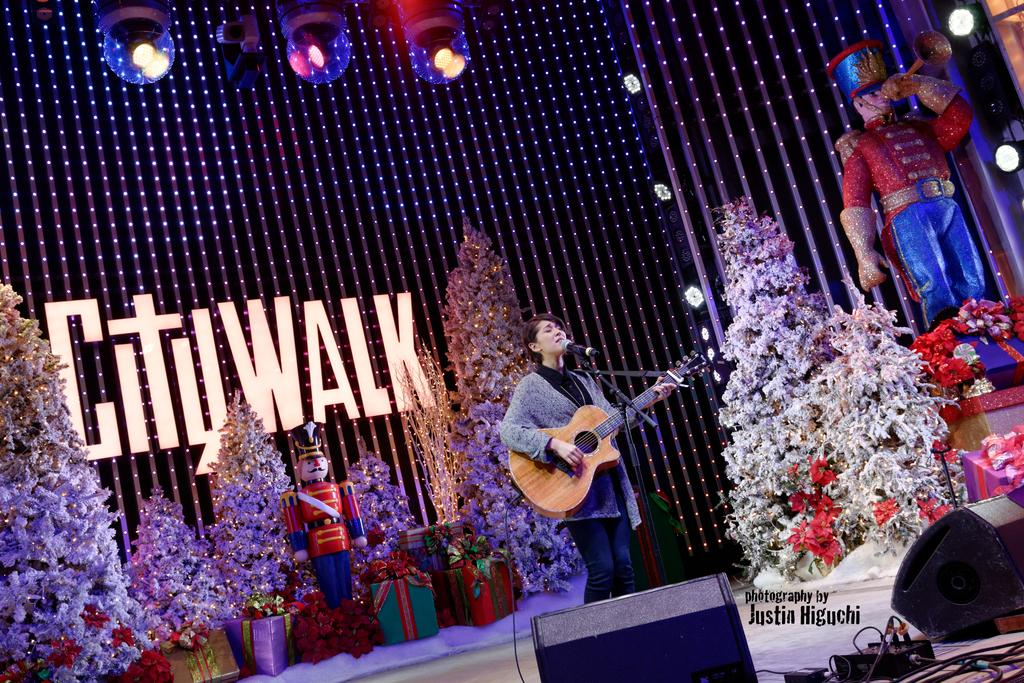Who is the main subject in the image? There is a woman in the image. What is the woman doing in the image? The woman is singing on a microphone and playing a guitar. Are there any objects or items present in the image besides the woman? Yes, there is a toy and bouquets in the image. What can be seen in the background of the image? There are lights visible in the background of the image. Can you tell me how many frogs are present in the image? There are no frogs present in the image. What type of route is the woman taking while playing the guitar? The image does not show the woman taking any route; she is stationary while playing the guitar and singing on a microphone. 